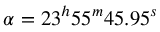<formula> <loc_0><loc_0><loc_500><loc_500>\alpha = 2 3 ^ { h } 5 5 ^ { m } 4 5 . 9 5 ^ { s }</formula> 